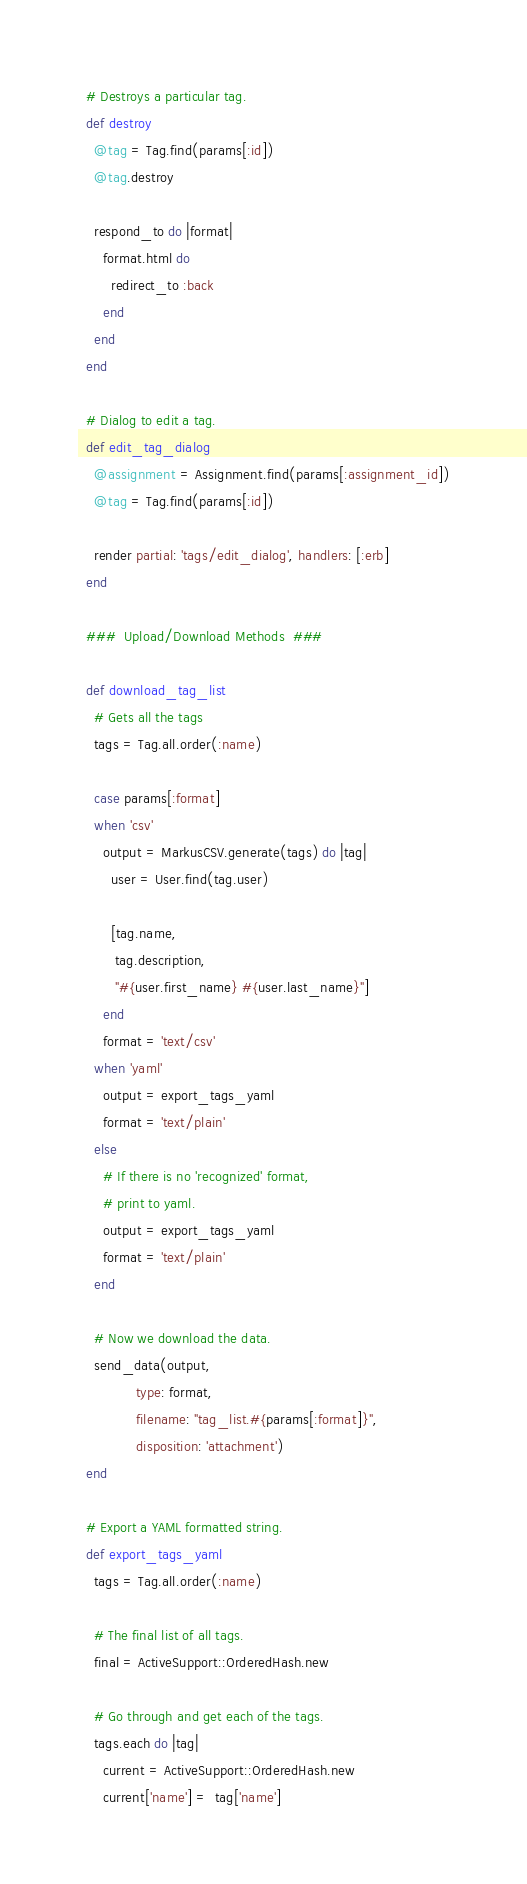Convert code to text. <code><loc_0><loc_0><loc_500><loc_500><_Ruby_>  # Destroys a particular tag.
  def destroy
    @tag = Tag.find(params[:id])
    @tag.destroy

    respond_to do |format|
      format.html do
        redirect_to :back
      end
    end
  end

  # Dialog to edit a tag.
  def edit_tag_dialog
    @assignment = Assignment.find(params[:assignment_id])
    @tag = Tag.find(params[:id])

    render partial: 'tags/edit_dialog', handlers: [:erb]
  end

  ###  Upload/Download Methods  ###

  def download_tag_list
    # Gets all the tags
    tags = Tag.all.order(:name)

    case params[:format]
    when 'csv'
      output = MarkusCSV.generate(tags) do |tag|
        user = User.find(tag.user)

        [tag.name,
         tag.description,
         "#{user.first_name} #{user.last_name}"]
      end
      format = 'text/csv'
    when 'yaml'
      output = export_tags_yaml
      format = 'text/plain'
    else
      # If there is no 'recognized' format,
      # print to yaml.
      output = export_tags_yaml
      format = 'text/plain'
    end

    # Now we download the data.
    send_data(output,
              type: format,
              filename: "tag_list.#{params[:format]}",
              disposition: 'attachment')
  end

  # Export a YAML formatted string.
  def export_tags_yaml
    tags = Tag.all.order(:name)

    # The final list of all tags.
    final = ActiveSupport::OrderedHash.new

    # Go through and get each of the tags.
    tags.each do |tag|
      current = ActiveSupport::OrderedHash.new
      current['name'] =  tag['name']</code> 